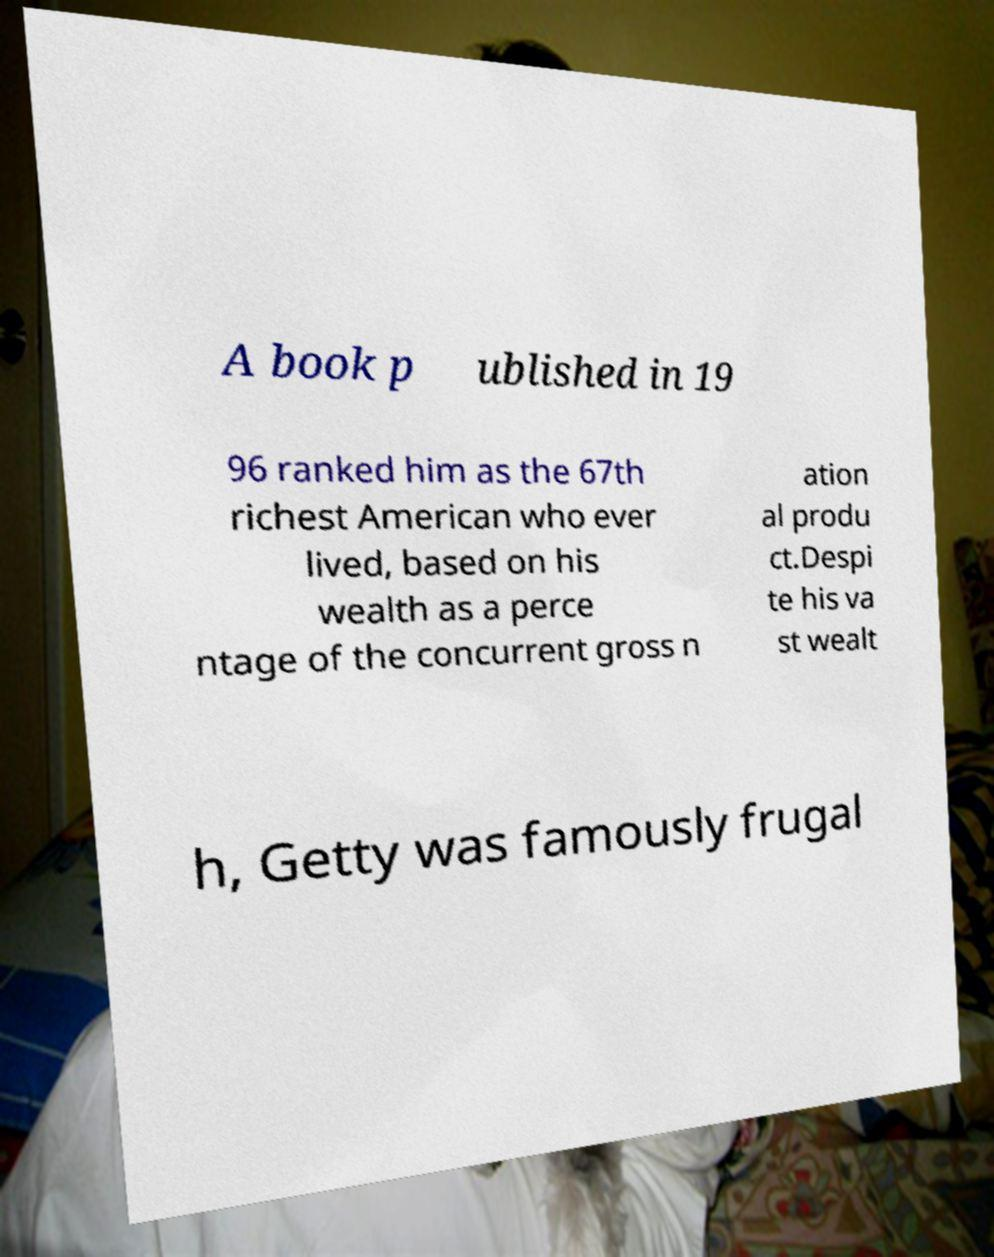Can you read and provide the text displayed in the image?This photo seems to have some interesting text. Can you extract and type it out for me? A book p ublished in 19 96 ranked him as the 67th richest American who ever lived, based on his wealth as a perce ntage of the concurrent gross n ation al produ ct.Despi te his va st wealt h, Getty was famously frugal 